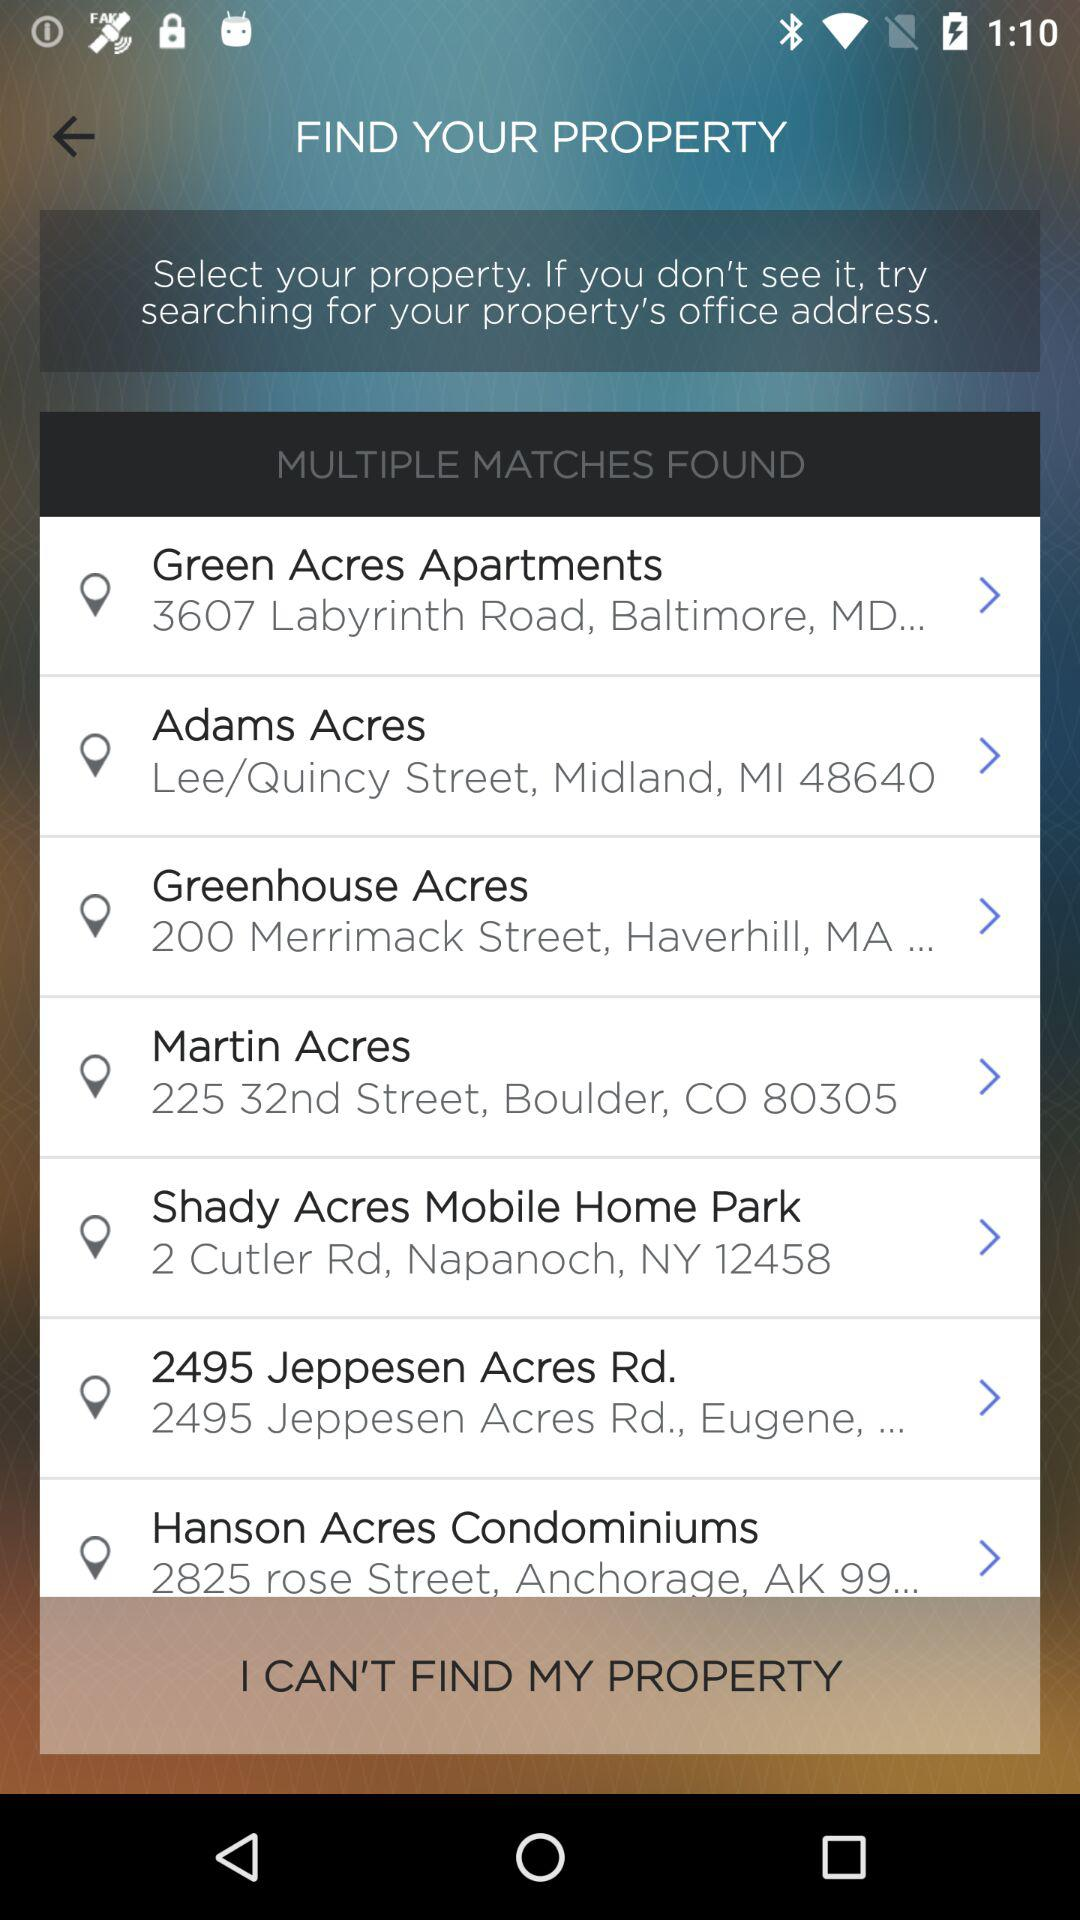What are the available properties? The available properties are "Green Acres Apartments", "Adams Acres", "Greenhouse Acres", "Martin Acres", "Shady Acres Mobile Home Park", "2495 Jeppesen Acres Rd." and "Hanson Acres Condominiums". 